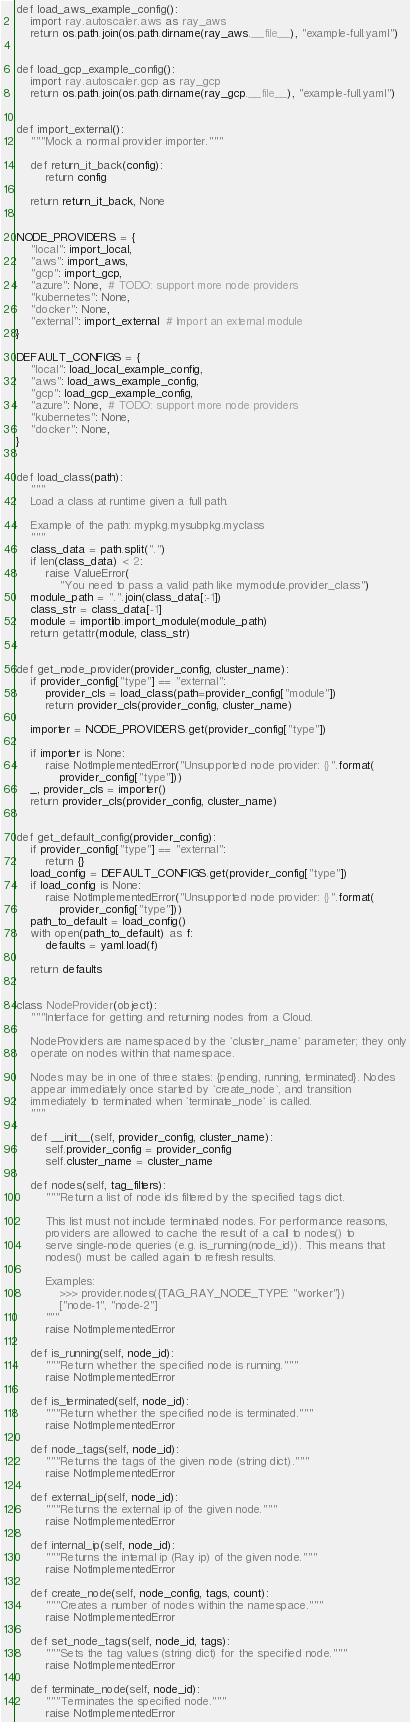Convert code to text. <code><loc_0><loc_0><loc_500><loc_500><_Python_>

def load_aws_example_config():
    import ray.autoscaler.aws as ray_aws
    return os.path.join(os.path.dirname(ray_aws.__file__), "example-full.yaml")


def load_gcp_example_config():
    import ray.autoscaler.gcp as ray_gcp
    return os.path.join(os.path.dirname(ray_gcp.__file__), "example-full.yaml")


def import_external():
    """Mock a normal provider importer."""

    def return_it_back(config):
        return config

    return return_it_back, None


NODE_PROVIDERS = {
    "local": import_local,
    "aws": import_aws,
    "gcp": import_gcp,
    "azure": None,  # TODO: support more node providers
    "kubernetes": None,
    "docker": None,
    "external": import_external  # Import an external module
}

DEFAULT_CONFIGS = {
    "local": load_local_example_config,
    "aws": load_aws_example_config,
    "gcp": load_gcp_example_config,
    "azure": None,  # TODO: support more node providers
    "kubernetes": None,
    "docker": None,
}


def load_class(path):
    """
    Load a class at runtime given a full path.

    Example of the path: mypkg.mysubpkg.myclass
    """
    class_data = path.split(".")
    if len(class_data) < 2:
        raise ValueError(
            "You need to pass a valid path like mymodule.provider_class")
    module_path = ".".join(class_data[:-1])
    class_str = class_data[-1]
    module = importlib.import_module(module_path)
    return getattr(module, class_str)


def get_node_provider(provider_config, cluster_name):
    if provider_config["type"] == "external":
        provider_cls = load_class(path=provider_config["module"])
        return provider_cls(provider_config, cluster_name)

    importer = NODE_PROVIDERS.get(provider_config["type"])

    if importer is None:
        raise NotImplementedError("Unsupported node provider: {}".format(
            provider_config["type"]))
    _, provider_cls = importer()
    return provider_cls(provider_config, cluster_name)


def get_default_config(provider_config):
    if provider_config["type"] == "external":
        return {}
    load_config = DEFAULT_CONFIGS.get(provider_config["type"])
    if load_config is None:
        raise NotImplementedError("Unsupported node provider: {}".format(
            provider_config["type"]))
    path_to_default = load_config()
    with open(path_to_default) as f:
        defaults = yaml.load(f)

    return defaults


class NodeProvider(object):
    """Interface for getting and returning nodes from a Cloud.

    NodeProviders are namespaced by the `cluster_name` parameter; they only
    operate on nodes within that namespace.

    Nodes may be in one of three states: {pending, running, terminated}. Nodes
    appear immediately once started by `create_node`, and transition
    immediately to terminated when `terminate_node` is called.
    """

    def __init__(self, provider_config, cluster_name):
        self.provider_config = provider_config
        self.cluster_name = cluster_name

    def nodes(self, tag_filters):
        """Return a list of node ids filtered by the specified tags dict.

        This list must not include terminated nodes. For performance reasons,
        providers are allowed to cache the result of a call to nodes() to
        serve single-node queries (e.g. is_running(node_id)). This means that
        nodes() must be called again to refresh results.

        Examples:
            >>> provider.nodes({TAG_RAY_NODE_TYPE: "worker"})
            ["node-1", "node-2"]
        """
        raise NotImplementedError

    def is_running(self, node_id):
        """Return whether the specified node is running."""
        raise NotImplementedError

    def is_terminated(self, node_id):
        """Return whether the specified node is terminated."""
        raise NotImplementedError

    def node_tags(self, node_id):
        """Returns the tags of the given node (string dict)."""
        raise NotImplementedError

    def external_ip(self, node_id):
        """Returns the external ip of the given node."""
        raise NotImplementedError

    def internal_ip(self, node_id):
        """Returns the internal ip (Ray ip) of the given node."""
        raise NotImplementedError

    def create_node(self, node_config, tags, count):
        """Creates a number of nodes within the namespace."""
        raise NotImplementedError

    def set_node_tags(self, node_id, tags):
        """Sets the tag values (string dict) for the specified node."""
        raise NotImplementedError

    def terminate_node(self, node_id):
        """Terminates the specified node."""
        raise NotImplementedError
</code> 